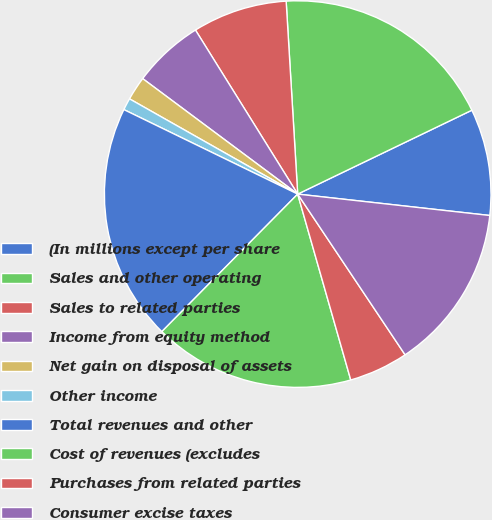Convert chart to OTSL. <chart><loc_0><loc_0><loc_500><loc_500><pie_chart><fcel>(In millions except per share<fcel>Sales and other operating<fcel>Sales to related parties<fcel>Income from equity method<fcel>Net gain on disposal of assets<fcel>Other income<fcel>Total revenues and other<fcel>Cost of revenues (excludes<fcel>Purchases from related parties<fcel>Consumer excise taxes<nl><fcel>8.91%<fcel>18.81%<fcel>7.92%<fcel>5.94%<fcel>1.99%<fcel>1.0%<fcel>19.8%<fcel>16.83%<fcel>4.95%<fcel>13.86%<nl></chart> 